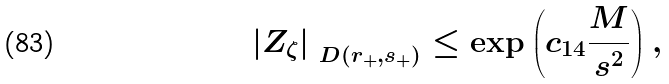Convert formula to latex. <formula><loc_0><loc_0><loc_500><loc_500>\left | Z _ { \zeta } \right | _ { \ D ( r _ { + } , s _ { + } ) } \leq \exp \left ( c _ { 1 4 } \frac { M } { s ^ { 2 } } \right ) ,</formula> 